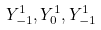Convert formula to latex. <formula><loc_0><loc_0><loc_500><loc_500>Y _ { - 1 } ^ { 1 } , Y _ { 0 } ^ { 1 } , Y _ { - 1 } ^ { 1 }</formula> 